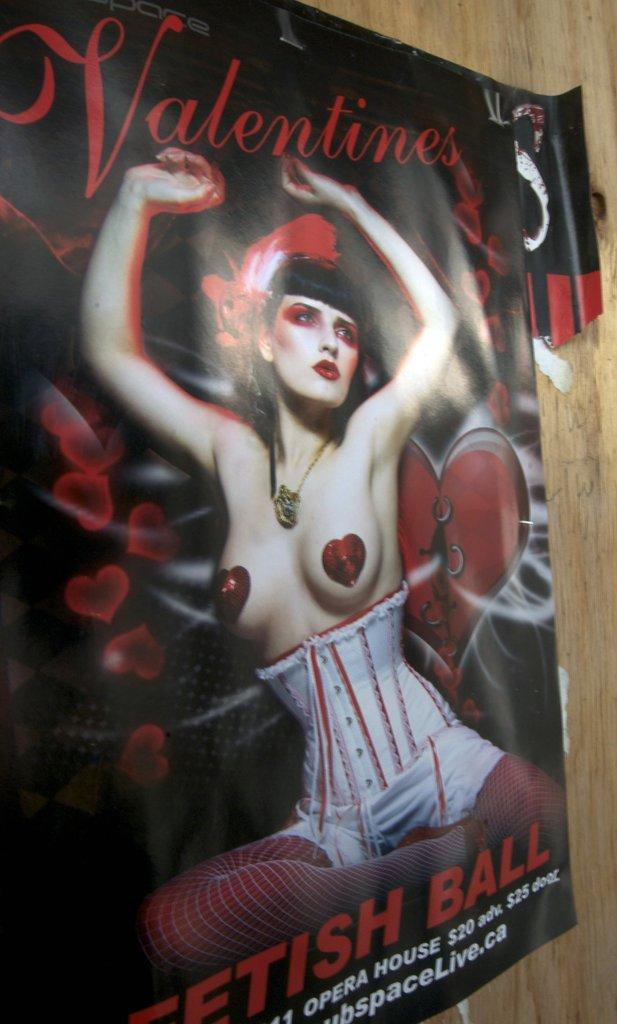What is depicted on the poster in the image? The poster features a woman. Where is the poster located in the image? The poster is stuck to a wall. What type of dress is the woman wearing in the poster? There is no information about the woman's dress in the image, as the focus is on the fact that the poster features a woman. 